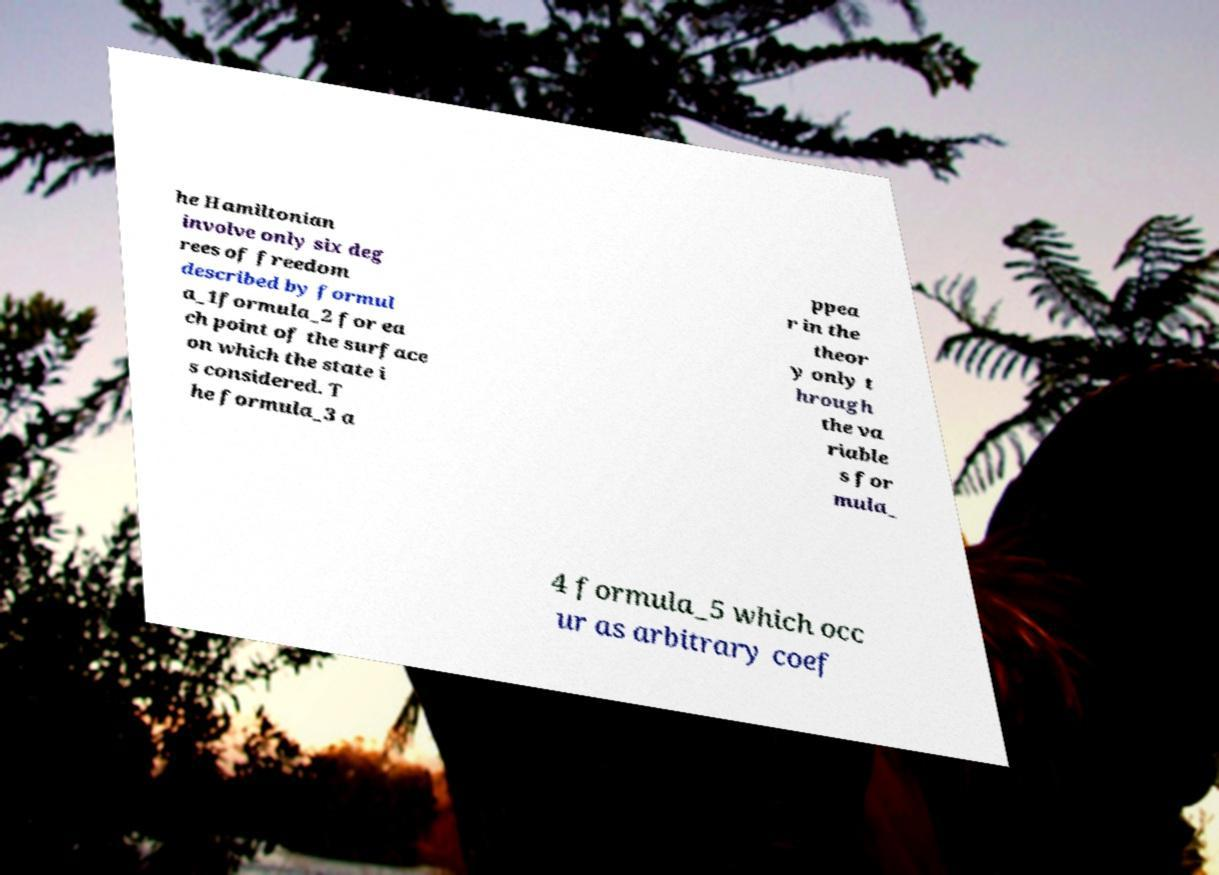Could you extract and type out the text from this image? he Hamiltonian involve only six deg rees of freedom described by formul a_1formula_2 for ea ch point of the surface on which the state i s considered. T he formula_3 a ppea r in the theor y only t hrough the va riable s for mula_ 4 formula_5 which occ ur as arbitrary coef 